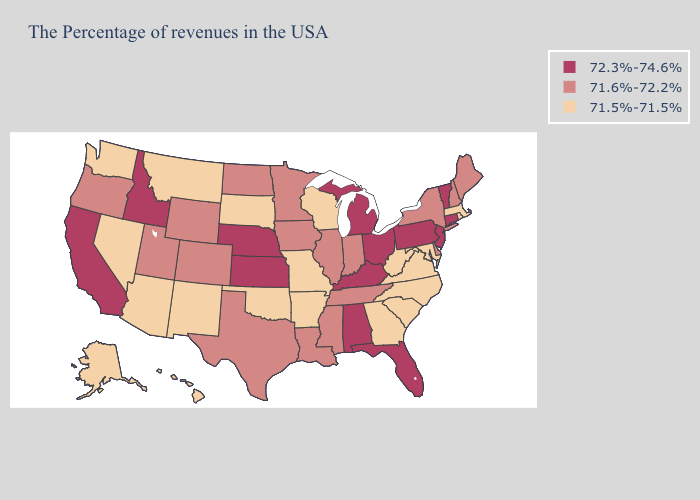What is the value of North Dakota?
Give a very brief answer. 71.6%-72.2%. Does Virginia have the highest value in the USA?
Short answer required. No. What is the value of Missouri?
Write a very short answer. 71.5%-71.5%. Does California have the highest value in the USA?
Concise answer only. Yes. Name the states that have a value in the range 71.5%-71.5%?
Write a very short answer. Massachusetts, Rhode Island, Maryland, Virginia, North Carolina, South Carolina, West Virginia, Georgia, Wisconsin, Missouri, Arkansas, Oklahoma, South Dakota, New Mexico, Montana, Arizona, Nevada, Washington, Alaska, Hawaii. What is the lowest value in the West?
Answer briefly. 71.5%-71.5%. What is the lowest value in the USA?
Concise answer only. 71.5%-71.5%. Among the states that border Idaho , which have the lowest value?
Short answer required. Montana, Nevada, Washington. What is the highest value in the South ?
Keep it brief. 72.3%-74.6%. What is the value of Maryland?
Answer briefly. 71.5%-71.5%. What is the highest value in the MidWest ?
Give a very brief answer. 72.3%-74.6%. Name the states that have a value in the range 71.5%-71.5%?
Give a very brief answer. Massachusetts, Rhode Island, Maryland, Virginia, North Carolina, South Carolina, West Virginia, Georgia, Wisconsin, Missouri, Arkansas, Oklahoma, South Dakota, New Mexico, Montana, Arizona, Nevada, Washington, Alaska, Hawaii. How many symbols are there in the legend?
Be succinct. 3. Among the states that border South Carolina , which have the highest value?
Answer briefly. North Carolina, Georgia. 